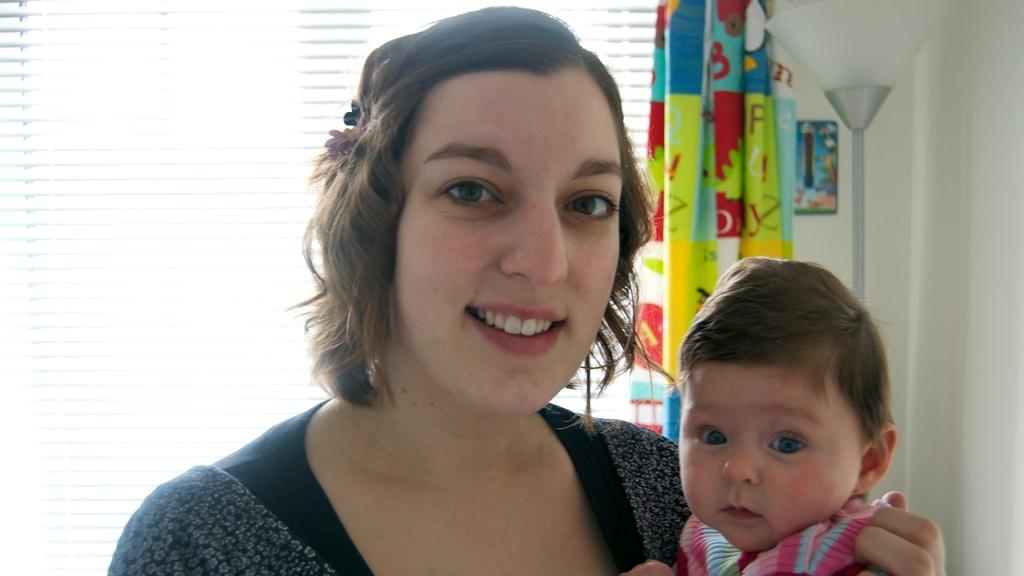Who is the main subject in the image? There is a woman in the image. What is the woman doing in the image? The woman is carrying a child. What can be seen in the background of the image? There is a curtain and a flag in the image. What is the source of light in the image? There is light in the image. Is there any other smaller image within the main image? Yes, there is a small image in the image. What type of sock is the woman wearing in the image? There is no sock visible in the image; the woman is carrying a child. What is the title of the small image within the main image? There is no title provided for the small image within the main image, as it is not mentioned in the facts. 